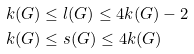<formula> <loc_0><loc_0><loc_500><loc_500>k ( G ) & \leq l ( G ) \leq 4 k ( G ) - 2 \\ k ( G ) & \leq s ( G ) \leq 4 k ( G )</formula> 